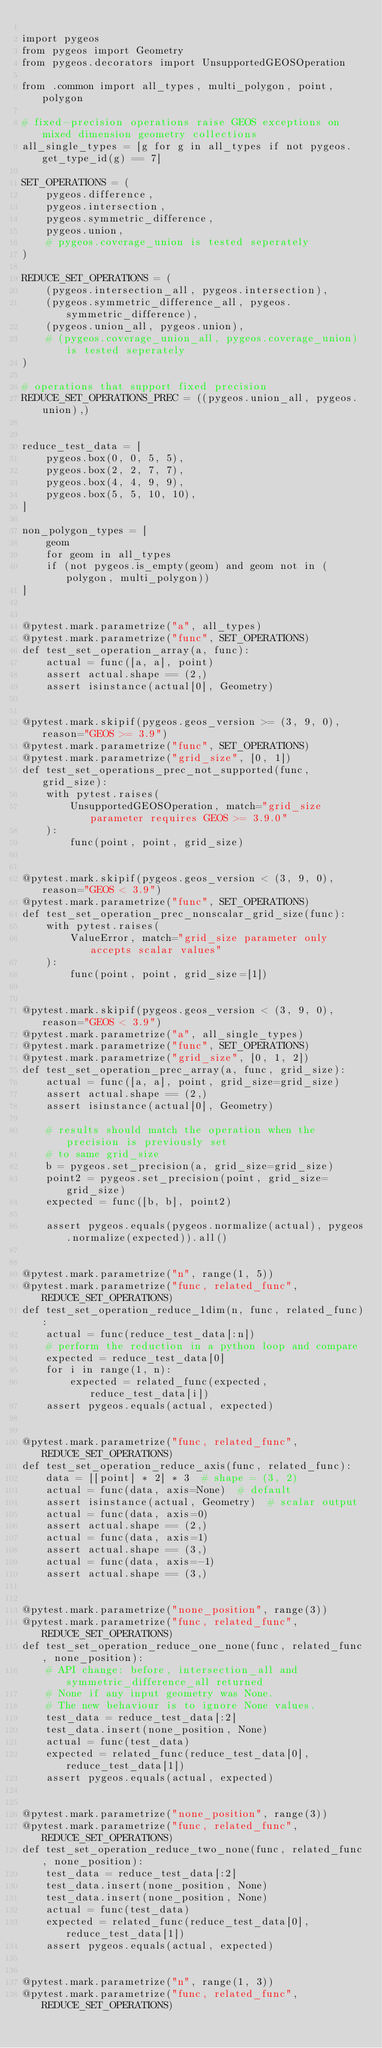<code> <loc_0><loc_0><loc_500><loc_500><_Python_>
import pygeos
from pygeos import Geometry
from pygeos.decorators import UnsupportedGEOSOperation

from .common import all_types, multi_polygon, point, polygon

# fixed-precision operations raise GEOS exceptions on mixed dimension geometry collections
all_single_types = [g for g in all_types if not pygeos.get_type_id(g) == 7]

SET_OPERATIONS = (
    pygeos.difference,
    pygeos.intersection,
    pygeos.symmetric_difference,
    pygeos.union,
    # pygeos.coverage_union is tested seperately
)

REDUCE_SET_OPERATIONS = (
    (pygeos.intersection_all, pygeos.intersection),
    (pygeos.symmetric_difference_all, pygeos.symmetric_difference),
    (pygeos.union_all, pygeos.union),
    # (pygeos.coverage_union_all, pygeos.coverage_union) is tested seperately
)

# operations that support fixed precision
REDUCE_SET_OPERATIONS_PREC = ((pygeos.union_all, pygeos.union),)


reduce_test_data = [
    pygeos.box(0, 0, 5, 5),
    pygeos.box(2, 2, 7, 7),
    pygeos.box(4, 4, 9, 9),
    pygeos.box(5, 5, 10, 10),
]

non_polygon_types = [
    geom
    for geom in all_types
    if (not pygeos.is_empty(geom) and geom not in (polygon, multi_polygon))
]


@pytest.mark.parametrize("a", all_types)
@pytest.mark.parametrize("func", SET_OPERATIONS)
def test_set_operation_array(a, func):
    actual = func([a, a], point)
    assert actual.shape == (2,)
    assert isinstance(actual[0], Geometry)


@pytest.mark.skipif(pygeos.geos_version >= (3, 9, 0), reason="GEOS >= 3.9")
@pytest.mark.parametrize("func", SET_OPERATIONS)
@pytest.mark.parametrize("grid_size", [0, 1])
def test_set_operations_prec_not_supported(func, grid_size):
    with pytest.raises(
        UnsupportedGEOSOperation, match="grid_size parameter requires GEOS >= 3.9.0"
    ):
        func(point, point, grid_size)


@pytest.mark.skipif(pygeos.geos_version < (3, 9, 0), reason="GEOS < 3.9")
@pytest.mark.parametrize("func", SET_OPERATIONS)
def test_set_operation_prec_nonscalar_grid_size(func):
    with pytest.raises(
        ValueError, match="grid_size parameter only accepts scalar values"
    ):
        func(point, point, grid_size=[1])


@pytest.mark.skipif(pygeos.geos_version < (3, 9, 0), reason="GEOS < 3.9")
@pytest.mark.parametrize("a", all_single_types)
@pytest.mark.parametrize("func", SET_OPERATIONS)
@pytest.mark.parametrize("grid_size", [0, 1, 2])
def test_set_operation_prec_array(a, func, grid_size):
    actual = func([a, a], point, grid_size=grid_size)
    assert actual.shape == (2,)
    assert isinstance(actual[0], Geometry)

    # results should match the operation when the precision is previously set
    # to same grid_size
    b = pygeos.set_precision(a, grid_size=grid_size)
    point2 = pygeos.set_precision(point, grid_size=grid_size)
    expected = func([b, b], point2)

    assert pygeos.equals(pygeos.normalize(actual), pygeos.normalize(expected)).all()


@pytest.mark.parametrize("n", range(1, 5))
@pytest.mark.parametrize("func, related_func", REDUCE_SET_OPERATIONS)
def test_set_operation_reduce_1dim(n, func, related_func):
    actual = func(reduce_test_data[:n])
    # perform the reduction in a python loop and compare
    expected = reduce_test_data[0]
    for i in range(1, n):
        expected = related_func(expected, reduce_test_data[i])
    assert pygeos.equals(actual, expected)


@pytest.mark.parametrize("func, related_func", REDUCE_SET_OPERATIONS)
def test_set_operation_reduce_axis(func, related_func):
    data = [[point] * 2] * 3  # shape = (3, 2)
    actual = func(data, axis=None)  # default
    assert isinstance(actual, Geometry)  # scalar output
    actual = func(data, axis=0)
    assert actual.shape == (2,)
    actual = func(data, axis=1)
    assert actual.shape == (3,)
    actual = func(data, axis=-1)
    assert actual.shape == (3,)


@pytest.mark.parametrize("none_position", range(3))
@pytest.mark.parametrize("func, related_func", REDUCE_SET_OPERATIONS)
def test_set_operation_reduce_one_none(func, related_func, none_position):
    # API change: before, intersection_all and symmetric_difference_all returned
    # None if any input geometry was None.
    # The new behaviour is to ignore None values.
    test_data = reduce_test_data[:2]
    test_data.insert(none_position, None)
    actual = func(test_data)
    expected = related_func(reduce_test_data[0], reduce_test_data[1])
    assert pygeos.equals(actual, expected)


@pytest.mark.parametrize("none_position", range(3))
@pytest.mark.parametrize("func, related_func", REDUCE_SET_OPERATIONS)
def test_set_operation_reduce_two_none(func, related_func, none_position):
    test_data = reduce_test_data[:2]
    test_data.insert(none_position, None)
    test_data.insert(none_position, None)
    actual = func(test_data)
    expected = related_func(reduce_test_data[0], reduce_test_data[1])
    assert pygeos.equals(actual, expected)


@pytest.mark.parametrize("n", range(1, 3))
@pytest.mark.parametrize("func, related_func", REDUCE_SET_OPERATIONS)</code> 